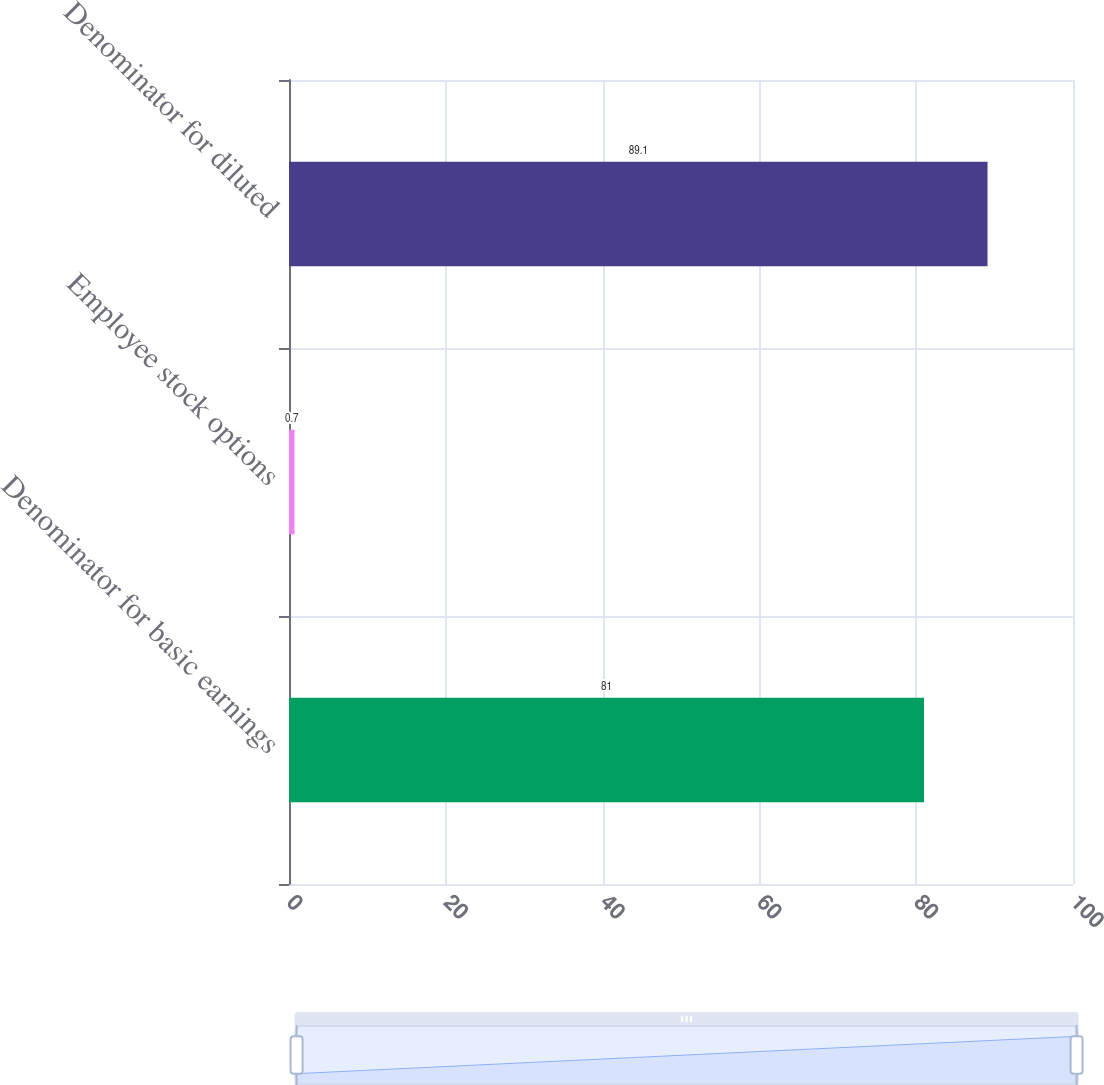Convert chart to OTSL. <chart><loc_0><loc_0><loc_500><loc_500><bar_chart><fcel>Denominator for basic earnings<fcel>Employee stock options<fcel>Denominator for diluted<nl><fcel>81<fcel>0.7<fcel>89.1<nl></chart> 